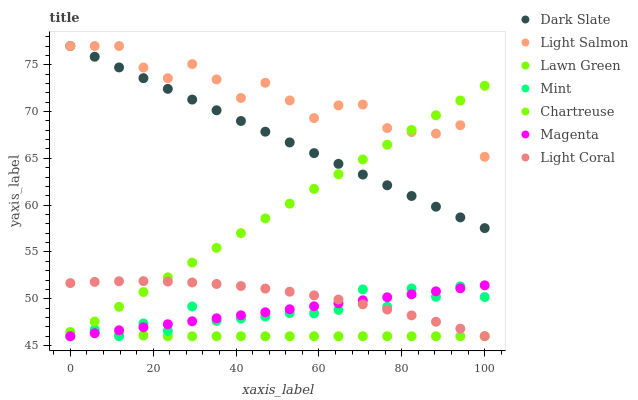Does Lawn Green have the minimum area under the curve?
Answer yes or no. Yes. Does Light Salmon have the maximum area under the curve?
Answer yes or no. Yes. Does Light Coral have the minimum area under the curve?
Answer yes or no. No. Does Light Coral have the maximum area under the curve?
Answer yes or no. No. Is Magenta the smoothest?
Answer yes or no. Yes. Is Mint the roughest?
Answer yes or no. Yes. Is Light Salmon the smoothest?
Answer yes or no. No. Is Light Salmon the roughest?
Answer yes or no. No. Does Lawn Green have the lowest value?
Answer yes or no. Yes. Does Light Coral have the lowest value?
Answer yes or no. No. Does Dark Slate have the highest value?
Answer yes or no. Yes. Does Light Coral have the highest value?
Answer yes or no. No. Is Light Coral less than Light Salmon?
Answer yes or no. Yes. Is Light Salmon greater than Light Coral?
Answer yes or no. Yes. Does Chartreuse intersect Light Coral?
Answer yes or no. Yes. Is Chartreuse less than Light Coral?
Answer yes or no. No. Is Chartreuse greater than Light Coral?
Answer yes or no. No. Does Light Coral intersect Light Salmon?
Answer yes or no. No. 